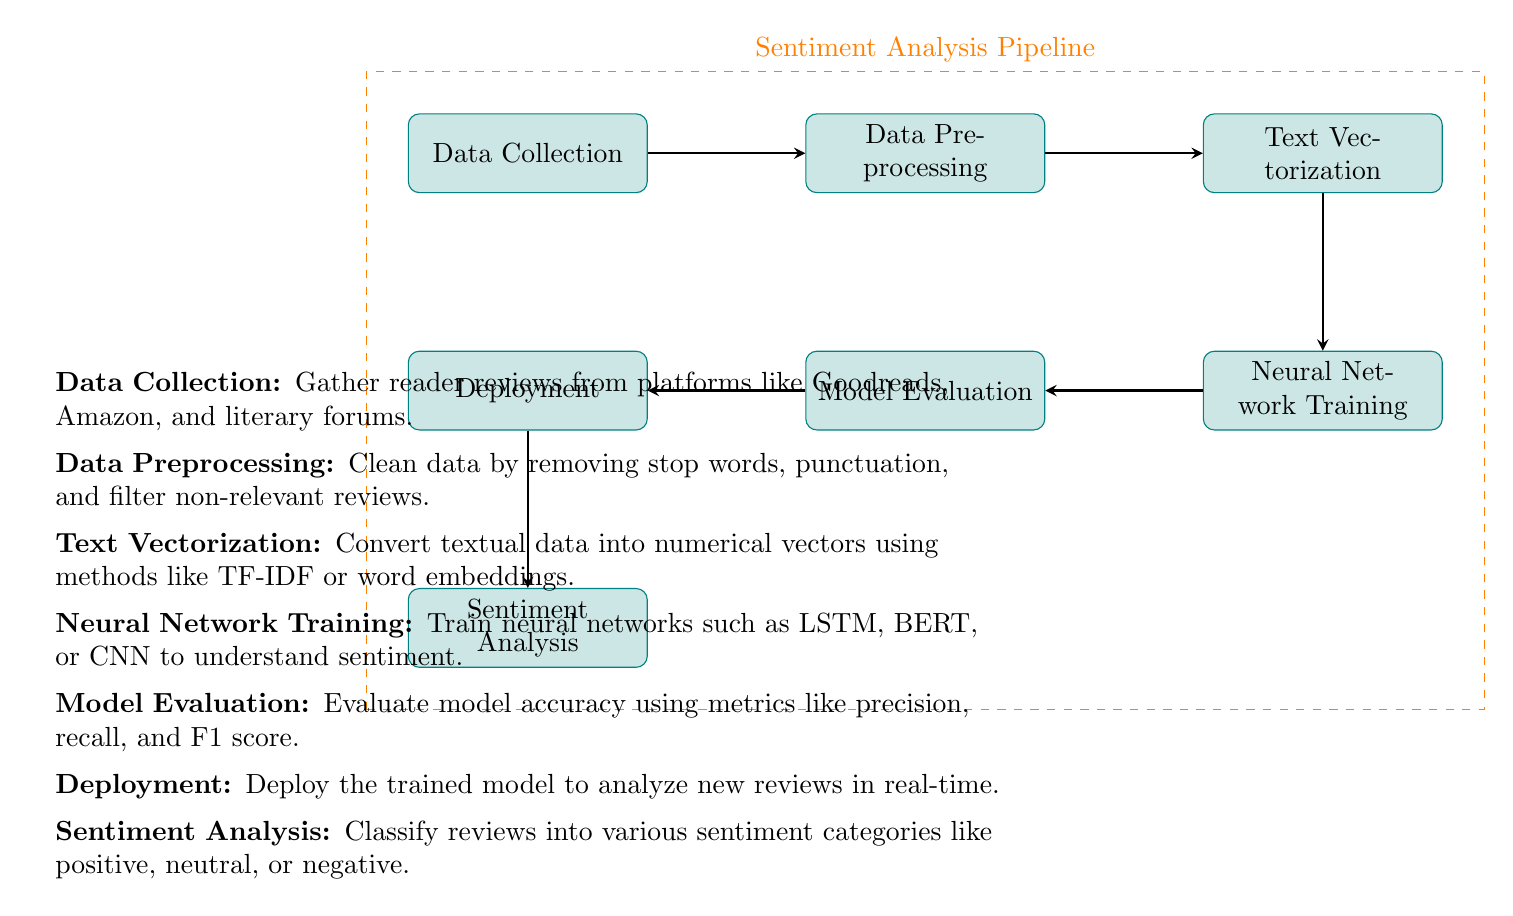What is the first step in the sentiment analysis pipeline? The diagram shows 'Data Collection' as the first node in the process, indicating it is the initial step for gathering reader reviews.
Answer: Data Collection Which method is used in the 'Text Vectorization' step? According to the diagram, 'Text Vectorization' uses methods such as TF-IDF or word embeddings to convert text into numerical vectors.
Answer: TF-IDF or word embeddings How many processes are depicted in the diagram? Counting the distinct nodes in the diagram, there are a total of seven processes represented.
Answer: Seven What follows 'Model Evaluation' in the pipeline? The arrow connecting 'Model Evaluation' to 'Deployment' indicates that 'Deployment' is the subsequent step in the process flow.
Answer: Deployment Which technology can be employed in 'Neural Network Training'? The diagram lists LSTM, BERT, or CNN as examples of neural networks that can be trained in this step.
Answer: LSTM, BERT, or CNN What type of analysis is the final output of the pipeline? The last node in the diagram indicates that the outcome of the pipeline is 'Sentiment Analysis', which classifies the reviews.
Answer: Sentiment Analysis How does 'Data Preprocessing' relate to 'Data Collection'? The diagram shows a direct arrow from 'Data Collection' to 'Data Preprocessing', illustrating that the latter step immediately follows the former.
Answer: Directly Which metric is mentioned for 'Model Evaluation'? The diagram states that metrics like precision, recall, and F1 score are used for evaluating the model’s accuracy in this step.
Answer: Precision, recall, and F1 score What occurs immediately before 'Sentiment Analysis'? The diagram shows that 'Deployment' occurs just before 'Sentiment Analysis', indicating the model must first be deployed to analyze reviews.
Answer: Deployment 